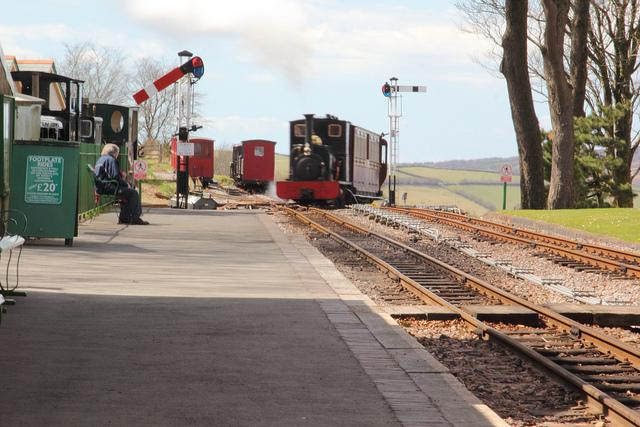What type facility is shown?

Choices:
A) train race
B) bus stop
C) train depot
D) taxi stand train depot 